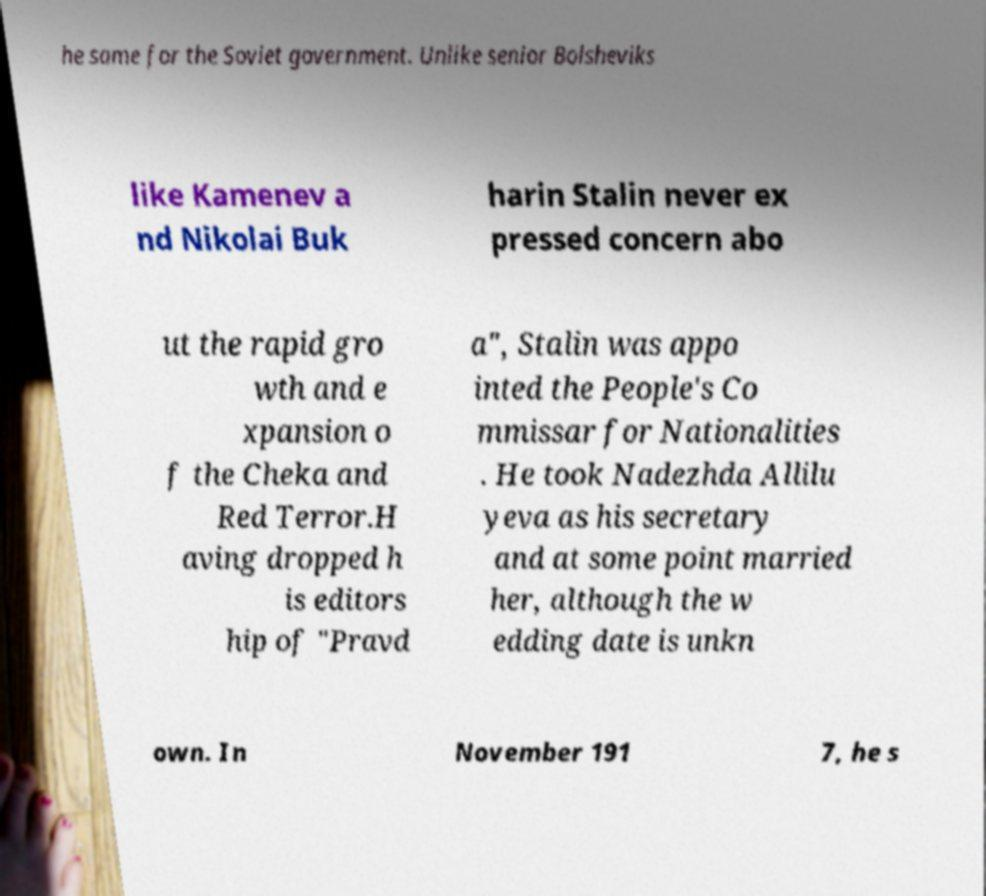For documentation purposes, I need the text within this image transcribed. Could you provide that? he same for the Soviet government. Unlike senior Bolsheviks like Kamenev a nd Nikolai Buk harin Stalin never ex pressed concern abo ut the rapid gro wth and e xpansion o f the Cheka and Red Terror.H aving dropped h is editors hip of "Pravd a", Stalin was appo inted the People's Co mmissar for Nationalities . He took Nadezhda Allilu yeva as his secretary and at some point married her, although the w edding date is unkn own. In November 191 7, he s 